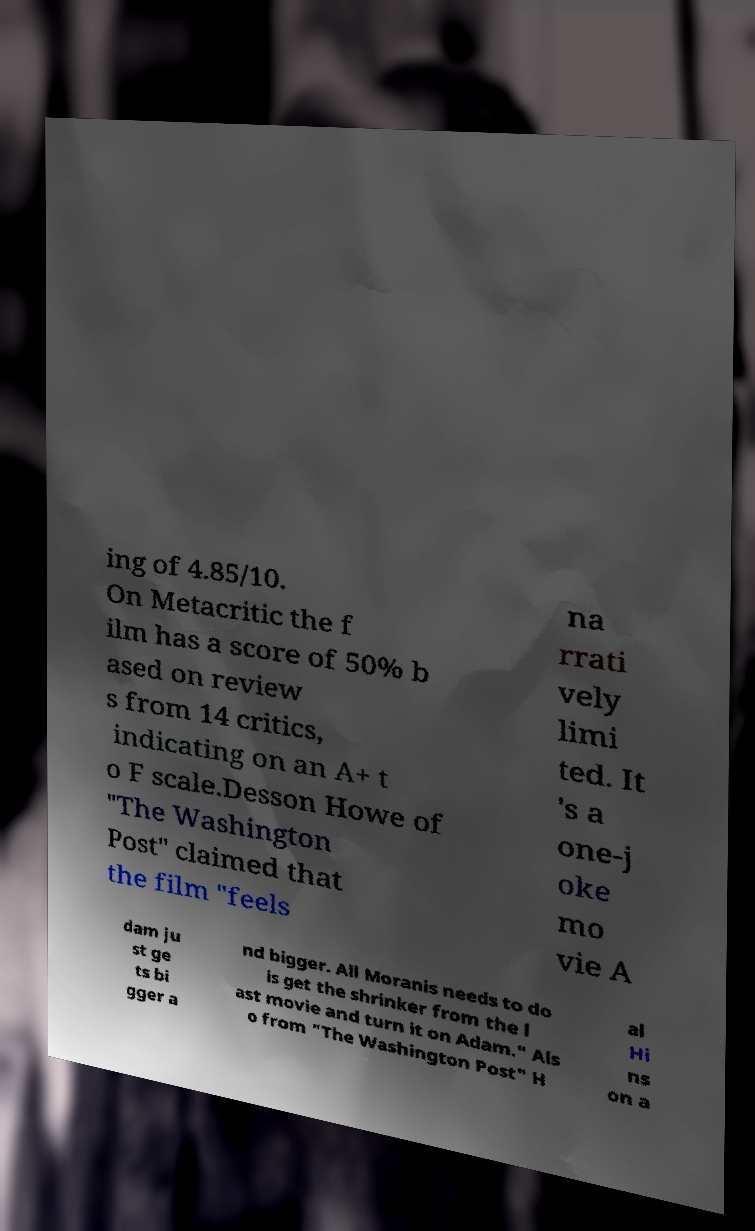Please identify and transcribe the text found in this image. ing of 4.85/10. On Metacritic the f ilm has a score of 50% b ased on review s from 14 critics, indicating on an A+ t o F scale.Desson Howe of "The Washington Post" claimed that the film "feels na rrati vely limi ted. It 's a one-j oke mo vie A dam ju st ge ts bi gger a nd bigger. All Moranis needs to do is get the shrinker from the l ast movie and turn it on Adam." Als o from "The Washington Post" H al Hi ns on a 